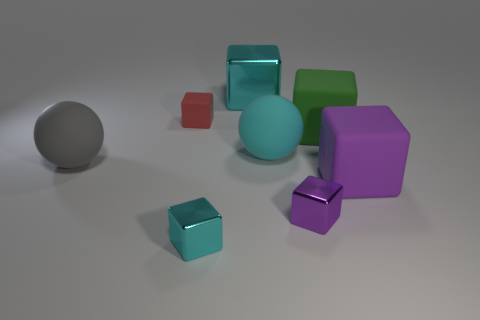Subtract 1 spheres. How many spheres are left? 1 Add 2 small cyan blocks. How many objects exist? 10 Subtract all large green cubes. How many cubes are left? 5 Subtract all cyan blocks. How many blocks are left? 4 Subtract all blocks. How many objects are left? 2 Subtract all red blocks. Subtract all gray spheres. How many blocks are left? 5 Subtract all green spheres. How many yellow cubes are left? 0 Subtract all large purple metallic cylinders. Subtract all large purple rubber cubes. How many objects are left? 7 Add 7 big purple rubber things. How many big purple rubber things are left? 8 Add 5 yellow matte cylinders. How many yellow matte cylinders exist? 5 